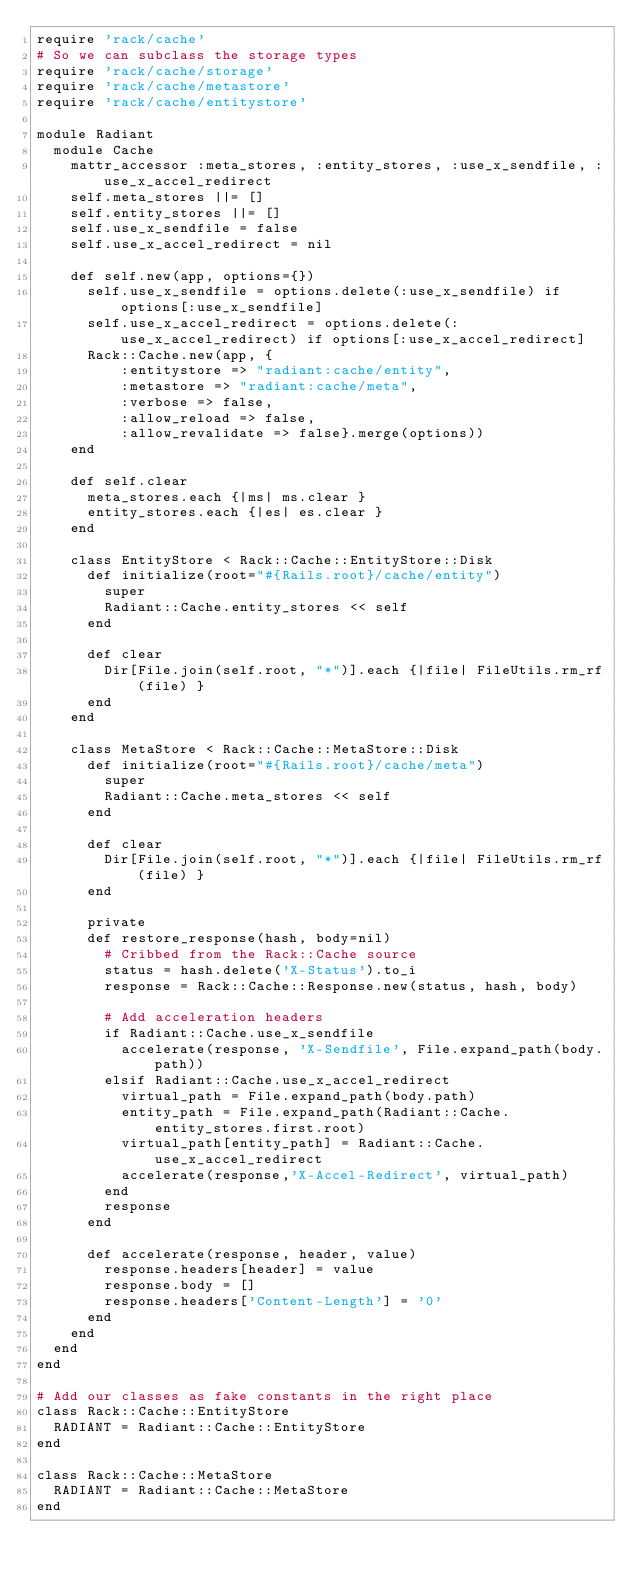<code> <loc_0><loc_0><loc_500><loc_500><_Ruby_>require 'rack/cache'
# So we can subclass the storage types
require 'rack/cache/storage'
require 'rack/cache/metastore'
require 'rack/cache/entitystore'

module Radiant
  module Cache
    mattr_accessor :meta_stores, :entity_stores, :use_x_sendfile, :use_x_accel_redirect
    self.meta_stores ||= []
    self.entity_stores ||= []
    self.use_x_sendfile = false
    self.use_x_accel_redirect = nil

    def self.new(app, options={})
      self.use_x_sendfile = options.delete(:use_x_sendfile) if options[:use_x_sendfile]
      self.use_x_accel_redirect = options.delete(:use_x_accel_redirect) if options[:use_x_accel_redirect]
      Rack::Cache.new(app, {
          :entitystore => "radiant:cache/entity", 
          :metastore => "radiant:cache/meta",
          :verbose => false,
          :allow_reload => false,
          :allow_revalidate => false}.merge(options))
    end

    def self.clear
      meta_stores.each {|ms| ms.clear }
      entity_stores.each {|es| es.clear }
    end

    class EntityStore < Rack::Cache::EntityStore::Disk
      def initialize(root="#{Rails.root}/cache/entity")
        super
        Radiant::Cache.entity_stores << self
      end

      def clear
        Dir[File.join(self.root, "*")].each {|file| FileUtils.rm_rf(file) }
      end
    end

    class MetaStore < Rack::Cache::MetaStore::Disk
      def initialize(root="#{Rails.root}/cache/meta")
        super
        Radiant::Cache.meta_stores << self
      end

      def clear
        Dir[File.join(self.root, "*")].each {|file| FileUtils.rm_rf(file) }
      end

      private
      def restore_response(hash, body=nil)
        # Cribbed from the Rack::Cache source
        status = hash.delete('X-Status').to_i
        response = Rack::Cache::Response.new(status, hash, body)

        # Add acceleration headers
        if Radiant::Cache.use_x_sendfile
          accelerate(response, 'X-Sendfile', File.expand_path(body.path))
        elsif Radiant::Cache.use_x_accel_redirect
          virtual_path = File.expand_path(body.path) 
          entity_path = File.expand_path(Radiant::Cache.entity_stores.first.root)
          virtual_path[entity_path] = Radiant::Cache.use_x_accel_redirect
          accelerate(response,'X-Accel-Redirect', virtual_path)
        end
        response
      end
      
      def accelerate(response, header, value)
        response.headers[header] = value
        response.body = []
        response.headers['Content-Length'] = '0'
      end
    end
  end
end

# Add our classes as fake constants in the right place
class Rack::Cache::EntityStore
  RADIANT = Radiant::Cache::EntityStore
end

class Rack::Cache::MetaStore
  RADIANT = Radiant::Cache::MetaStore
end</code> 